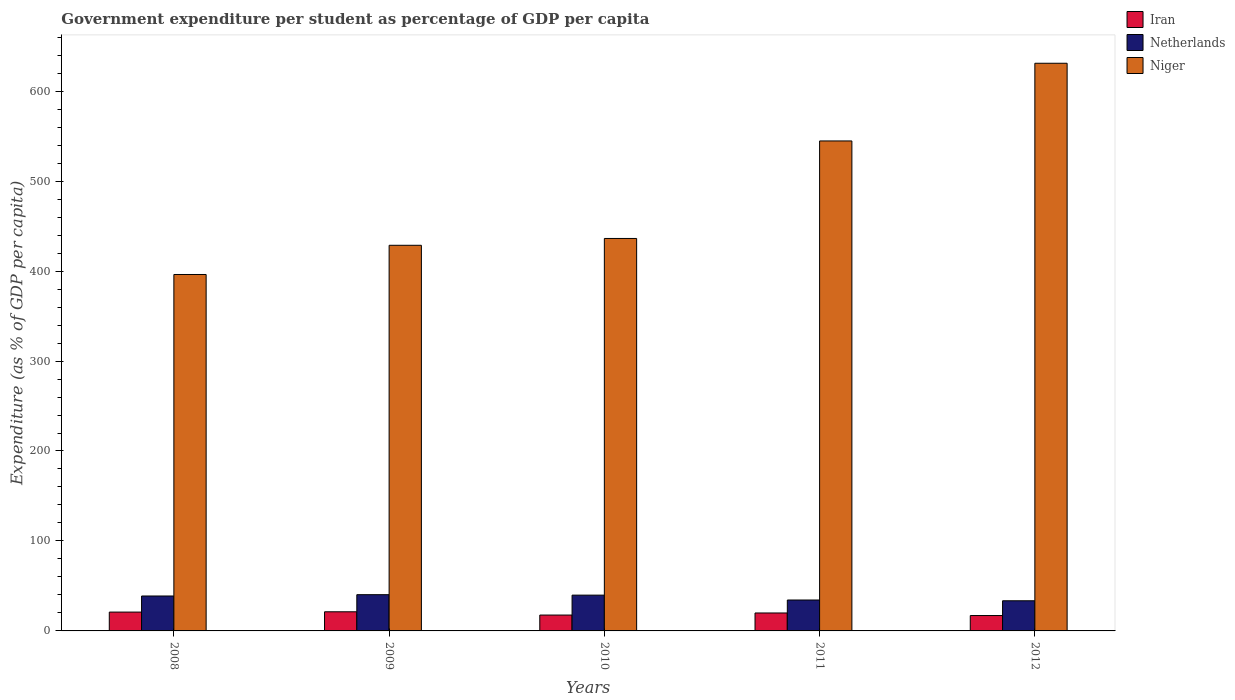How many groups of bars are there?
Offer a very short reply. 5. Are the number of bars per tick equal to the number of legend labels?
Make the answer very short. Yes. Are the number of bars on each tick of the X-axis equal?
Keep it short and to the point. Yes. How many bars are there on the 3rd tick from the right?
Ensure brevity in your answer.  3. What is the percentage of expenditure per student in Niger in 2011?
Keep it short and to the point. 544.64. Across all years, what is the maximum percentage of expenditure per student in Niger?
Offer a terse response. 631. Across all years, what is the minimum percentage of expenditure per student in Netherlands?
Offer a terse response. 33.51. In which year was the percentage of expenditure per student in Netherlands maximum?
Your answer should be very brief. 2009. What is the total percentage of expenditure per student in Niger in the graph?
Offer a very short reply. 2436.77. What is the difference between the percentage of expenditure per student in Niger in 2009 and that in 2011?
Your response must be concise. -115.99. What is the difference between the percentage of expenditure per student in Iran in 2008 and the percentage of expenditure per student in Niger in 2012?
Give a very brief answer. -610.06. What is the average percentage of expenditure per student in Netherlands per year?
Keep it short and to the point. 37.35. In the year 2012, what is the difference between the percentage of expenditure per student in Netherlands and percentage of expenditure per student in Niger?
Your answer should be very brief. -597.49. In how many years, is the percentage of expenditure per student in Niger greater than 60 %?
Give a very brief answer. 5. What is the ratio of the percentage of expenditure per student in Netherlands in 2009 to that in 2011?
Provide a succinct answer. 1.17. Is the percentage of expenditure per student in Niger in 2009 less than that in 2011?
Offer a terse response. Yes. Is the difference between the percentage of expenditure per student in Netherlands in 2008 and 2009 greater than the difference between the percentage of expenditure per student in Niger in 2008 and 2009?
Offer a terse response. Yes. What is the difference between the highest and the second highest percentage of expenditure per student in Netherlands?
Provide a succinct answer. 0.51. What is the difference between the highest and the lowest percentage of expenditure per student in Niger?
Your answer should be compact. 234.8. In how many years, is the percentage of expenditure per student in Niger greater than the average percentage of expenditure per student in Niger taken over all years?
Offer a terse response. 2. Is the sum of the percentage of expenditure per student in Iran in 2008 and 2012 greater than the maximum percentage of expenditure per student in Netherlands across all years?
Your answer should be compact. No. What does the 1st bar from the left in 2009 represents?
Offer a terse response. Iran. How many bars are there?
Your answer should be very brief. 15. Are all the bars in the graph horizontal?
Offer a terse response. No. How many years are there in the graph?
Provide a short and direct response. 5. What is the difference between two consecutive major ticks on the Y-axis?
Your response must be concise. 100. Does the graph contain any zero values?
Provide a succinct answer. No. Does the graph contain grids?
Your answer should be very brief. No. How many legend labels are there?
Keep it short and to the point. 3. What is the title of the graph?
Your answer should be compact. Government expenditure per student as percentage of GDP per capita. Does "Niger" appear as one of the legend labels in the graph?
Offer a terse response. Yes. What is the label or title of the X-axis?
Offer a very short reply. Years. What is the label or title of the Y-axis?
Your answer should be very brief. Expenditure (as % of GDP per capita). What is the Expenditure (as % of GDP per capita) of Iran in 2008?
Offer a terse response. 20.95. What is the Expenditure (as % of GDP per capita) in Netherlands in 2008?
Your response must be concise. 38.82. What is the Expenditure (as % of GDP per capita) of Niger in 2008?
Your answer should be compact. 396.2. What is the Expenditure (as % of GDP per capita) in Iran in 2009?
Make the answer very short. 21.27. What is the Expenditure (as % of GDP per capita) in Netherlands in 2009?
Your answer should be very brief. 40.29. What is the Expenditure (as % of GDP per capita) in Niger in 2009?
Make the answer very short. 428.66. What is the Expenditure (as % of GDP per capita) of Iran in 2010?
Provide a short and direct response. 17.65. What is the Expenditure (as % of GDP per capita) in Netherlands in 2010?
Your response must be concise. 39.78. What is the Expenditure (as % of GDP per capita) in Niger in 2010?
Keep it short and to the point. 436.26. What is the Expenditure (as % of GDP per capita) of Iran in 2011?
Provide a succinct answer. 19.95. What is the Expenditure (as % of GDP per capita) of Netherlands in 2011?
Make the answer very short. 34.36. What is the Expenditure (as % of GDP per capita) of Niger in 2011?
Your answer should be very brief. 544.64. What is the Expenditure (as % of GDP per capita) in Iran in 2012?
Your answer should be compact. 17.09. What is the Expenditure (as % of GDP per capita) of Netherlands in 2012?
Your answer should be very brief. 33.51. What is the Expenditure (as % of GDP per capita) in Niger in 2012?
Provide a short and direct response. 631. Across all years, what is the maximum Expenditure (as % of GDP per capita) in Iran?
Offer a terse response. 21.27. Across all years, what is the maximum Expenditure (as % of GDP per capita) of Netherlands?
Your response must be concise. 40.29. Across all years, what is the maximum Expenditure (as % of GDP per capita) in Niger?
Ensure brevity in your answer.  631. Across all years, what is the minimum Expenditure (as % of GDP per capita) in Iran?
Ensure brevity in your answer.  17.09. Across all years, what is the minimum Expenditure (as % of GDP per capita) in Netherlands?
Offer a terse response. 33.51. Across all years, what is the minimum Expenditure (as % of GDP per capita) in Niger?
Provide a short and direct response. 396.2. What is the total Expenditure (as % of GDP per capita) in Iran in the graph?
Keep it short and to the point. 96.9. What is the total Expenditure (as % of GDP per capita) of Netherlands in the graph?
Your answer should be very brief. 186.77. What is the total Expenditure (as % of GDP per capita) of Niger in the graph?
Make the answer very short. 2436.77. What is the difference between the Expenditure (as % of GDP per capita) in Iran in 2008 and that in 2009?
Offer a terse response. -0.32. What is the difference between the Expenditure (as % of GDP per capita) of Netherlands in 2008 and that in 2009?
Provide a short and direct response. -1.47. What is the difference between the Expenditure (as % of GDP per capita) of Niger in 2008 and that in 2009?
Offer a very short reply. -32.45. What is the difference between the Expenditure (as % of GDP per capita) in Iran in 2008 and that in 2010?
Provide a short and direct response. 3.3. What is the difference between the Expenditure (as % of GDP per capita) of Netherlands in 2008 and that in 2010?
Provide a succinct answer. -0.95. What is the difference between the Expenditure (as % of GDP per capita) of Niger in 2008 and that in 2010?
Your response must be concise. -40.05. What is the difference between the Expenditure (as % of GDP per capita) of Iran in 2008 and that in 2011?
Your response must be concise. 1. What is the difference between the Expenditure (as % of GDP per capita) in Netherlands in 2008 and that in 2011?
Offer a very short reply. 4.46. What is the difference between the Expenditure (as % of GDP per capita) in Niger in 2008 and that in 2011?
Offer a very short reply. -148.44. What is the difference between the Expenditure (as % of GDP per capita) in Iran in 2008 and that in 2012?
Give a very brief answer. 3.85. What is the difference between the Expenditure (as % of GDP per capita) of Netherlands in 2008 and that in 2012?
Your answer should be very brief. 5.31. What is the difference between the Expenditure (as % of GDP per capita) of Niger in 2008 and that in 2012?
Your response must be concise. -234.8. What is the difference between the Expenditure (as % of GDP per capita) of Iran in 2009 and that in 2010?
Offer a very short reply. 3.62. What is the difference between the Expenditure (as % of GDP per capita) in Netherlands in 2009 and that in 2010?
Offer a terse response. 0.51. What is the difference between the Expenditure (as % of GDP per capita) in Niger in 2009 and that in 2010?
Your answer should be compact. -7.6. What is the difference between the Expenditure (as % of GDP per capita) of Iran in 2009 and that in 2011?
Your response must be concise. 1.32. What is the difference between the Expenditure (as % of GDP per capita) in Netherlands in 2009 and that in 2011?
Your response must be concise. 5.93. What is the difference between the Expenditure (as % of GDP per capita) of Niger in 2009 and that in 2011?
Your answer should be compact. -115.99. What is the difference between the Expenditure (as % of GDP per capita) of Iran in 2009 and that in 2012?
Your answer should be compact. 4.17. What is the difference between the Expenditure (as % of GDP per capita) of Netherlands in 2009 and that in 2012?
Give a very brief answer. 6.78. What is the difference between the Expenditure (as % of GDP per capita) of Niger in 2009 and that in 2012?
Ensure brevity in your answer.  -202.35. What is the difference between the Expenditure (as % of GDP per capita) in Iran in 2010 and that in 2011?
Offer a very short reply. -2.3. What is the difference between the Expenditure (as % of GDP per capita) of Netherlands in 2010 and that in 2011?
Provide a short and direct response. 5.42. What is the difference between the Expenditure (as % of GDP per capita) of Niger in 2010 and that in 2011?
Ensure brevity in your answer.  -108.39. What is the difference between the Expenditure (as % of GDP per capita) in Iran in 2010 and that in 2012?
Your answer should be compact. 0.55. What is the difference between the Expenditure (as % of GDP per capita) in Netherlands in 2010 and that in 2012?
Your response must be concise. 6.27. What is the difference between the Expenditure (as % of GDP per capita) in Niger in 2010 and that in 2012?
Your response must be concise. -194.75. What is the difference between the Expenditure (as % of GDP per capita) in Iran in 2011 and that in 2012?
Ensure brevity in your answer.  2.85. What is the difference between the Expenditure (as % of GDP per capita) of Netherlands in 2011 and that in 2012?
Keep it short and to the point. 0.85. What is the difference between the Expenditure (as % of GDP per capita) of Niger in 2011 and that in 2012?
Your response must be concise. -86.36. What is the difference between the Expenditure (as % of GDP per capita) of Iran in 2008 and the Expenditure (as % of GDP per capita) of Netherlands in 2009?
Keep it short and to the point. -19.34. What is the difference between the Expenditure (as % of GDP per capita) of Iran in 2008 and the Expenditure (as % of GDP per capita) of Niger in 2009?
Offer a terse response. -407.71. What is the difference between the Expenditure (as % of GDP per capita) in Netherlands in 2008 and the Expenditure (as % of GDP per capita) in Niger in 2009?
Your answer should be compact. -389.83. What is the difference between the Expenditure (as % of GDP per capita) of Iran in 2008 and the Expenditure (as % of GDP per capita) of Netherlands in 2010?
Keep it short and to the point. -18.83. What is the difference between the Expenditure (as % of GDP per capita) in Iran in 2008 and the Expenditure (as % of GDP per capita) in Niger in 2010?
Offer a terse response. -415.31. What is the difference between the Expenditure (as % of GDP per capita) in Netherlands in 2008 and the Expenditure (as % of GDP per capita) in Niger in 2010?
Your response must be concise. -397.43. What is the difference between the Expenditure (as % of GDP per capita) in Iran in 2008 and the Expenditure (as % of GDP per capita) in Netherlands in 2011?
Keep it short and to the point. -13.42. What is the difference between the Expenditure (as % of GDP per capita) in Iran in 2008 and the Expenditure (as % of GDP per capita) in Niger in 2011?
Provide a short and direct response. -523.7. What is the difference between the Expenditure (as % of GDP per capita) in Netherlands in 2008 and the Expenditure (as % of GDP per capita) in Niger in 2011?
Give a very brief answer. -505.82. What is the difference between the Expenditure (as % of GDP per capita) of Iran in 2008 and the Expenditure (as % of GDP per capita) of Netherlands in 2012?
Your answer should be compact. -12.57. What is the difference between the Expenditure (as % of GDP per capita) in Iran in 2008 and the Expenditure (as % of GDP per capita) in Niger in 2012?
Offer a terse response. -610.06. What is the difference between the Expenditure (as % of GDP per capita) of Netherlands in 2008 and the Expenditure (as % of GDP per capita) of Niger in 2012?
Give a very brief answer. -592.18. What is the difference between the Expenditure (as % of GDP per capita) in Iran in 2009 and the Expenditure (as % of GDP per capita) in Netherlands in 2010?
Offer a terse response. -18.51. What is the difference between the Expenditure (as % of GDP per capita) of Iran in 2009 and the Expenditure (as % of GDP per capita) of Niger in 2010?
Your answer should be very brief. -414.99. What is the difference between the Expenditure (as % of GDP per capita) of Netherlands in 2009 and the Expenditure (as % of GDP per capita) of Niger in 2010?
Offer a very short reply. -395.97. What is the difference between the Expenditure (as % of GDP per capita) in Iran in 2009 and the Expenditure (as % of GDP per capita) in Netherlands in 2011?
Offer a very short reply. -13.1. What is the difference between the Expenditure (as % of GDP per capita) in Iran in 2009 and the Expenditure (as % of GDP per capita) in Niger in 2011?
Provide a succinct answer. -523.38. What is the difference between the Expenditure (as % of GDP per capita) of Netherlands in 2009 and the Expenditure (as % of GDP per capita) of Niger in 2011?
Provide a succinct answer. -504.36. What is the difference between the Expenditure (as % of GDP per capita) of Iran in 2009 and the Expenditure (as % of GDP per capita) of Netherlands in 2012?
Offer a terse response. -12.24. What is the difference between the Expenditure (as % of GDP per capita) of Iran in 2009 and the Expenditure (as % of GDP per capita) of Niger in 2012?
Provide a succinct answer. -609.74. What is the difference between the Expenditure (as % of GDP per capita) in Netherlands in 2009 and the Expenditure (as % of GDP per capita) in Niger in 2012?
Provide a succinct answer. -590.72. What is the difference between the Expenditure (as % of GDP per capita) of Iran in 2010 and the Expenditure (as % of GDP per capita) of Netherlands in 2011?
Your answer should be compact. -16.72. What is the difference between the Expenditure (as % of GDP per capita) of Iran in 2010 and the Expenditure (as % of GDP per capita) of Niger in 2011?
Offer a terse response. -527. What is the difference between the Expenditure (as % of GDP per capita) in Netherlands in 2010 and the Expenditure (as % of GDP per capita) in Niger in 2011?
Your response must be concise. -504.87. What is the difference between the Expenditure (as % of GDP per capita) in Iran in 2010 and the Expenditure (as % of GDP per capita) in Netherlands in 2012?
Give a very brief answer. -15.87. What is the difference between the Expenditure (as % of GDP per capita) of Iran in 2010 and the Expenditure (as % of GDP per capita) of Niger in 2012?
Your answer should be very brief. -613.36. What is the difference between the Expenditure (as % of GDP per capita) in Netherlands in 2010 and the Expenditure (as % of GDP per capita) in Niger in 2012?
Keep it short and to the point. -591.23. What is the difference between the Expenditure (as % of GDP per capita) of Iran in 2011 and the Expenditure (as % of GDP per capita) of Netherlands in 2012?
Your answer should be very brief. -13.56. What is the difference between the Expenditure (as % of GDP per capita) of Iran in 2011 and the Expenditure (as % of GDP per capita) of Niger in 2012?
Keep it short and to the point. -611.06. What is the difference between the Expenditure (as % of GDP per capita) in Netherlands in 2011 and the Expenditure (as % of GDP per capita) in Niger in 2012?
Provide a succinct answer. -596.64. What is the average Expenditure (as % of GDP per capita) in Iran per year?
Keep it short and to the point. 19.38. What is the average Expenditure (as % of GDP per capita) of Netherlands per year?
Offer a terse response. 37.35. What is the average Expenditure (as % of GDP per capita) in Niger per year?
Offer a terse response. 487.35. In the year 2008, what is the difference between the Expenditure (as % of GDP per capita) of Iran and Expenditure (as % of GDP per capita) of Netherlands?
Provide a short and direct response. -17.88. In the year 2008, what is the difference between the Expenditure (as % of GDP per capita) in Iran and Expenditure (as % of GDP per capita) in Niger?
Your response must be concise. -375.26. In the year 2008, what is the difference between the Expenditure (as % of GDP per capita) in Netherlands and Expenditure (as % of GDP per capita) in Niger?
Provide a succinct answer. -357.38. In the year 2009, what is the difference between the Expenditure (as % of GDP per capita) of Iran and Expenditure (as % of GDP per capita) of Netherlands?
Your answer should be compact. -19.02. In the year 2009, what is the difference between the Expenditure (as % of GDP per capita) in Iran and Expenditure (as % of GDP per capita) in Niger?
Keep it short and to the point. -407.39. In the year 2009, what is the difference between the Expenditure (as % of GDP per capita) of Netherlands and Expenditure (as % of GDP per capita) of Niger?
Your response must be concise. -388.37. In the year 2010, what is the difference between the Expenditure (as % of GDP per capita) of Iran and Expenditure (as % of GDP per capita) of Netherlands?
Make the answer very short. -22.13. In the year 2010, what is the difference between the Expenditure (as % of GDP per capita) in Iran and Expenditure (as % of GDP per capita) in Niger?
Your answer should be very brief. -418.61. In the year 2010, what is the difference between the Expenditure (as % of GDP per capita) of Netherlands and Expenditure (as % of GDP per capita) of Niger?
Provide a succinct answer. -396.48. In the year 2011, what is the difference between the Expenditure (as % of GDP per capita) in Iran and Expenditure (as % of GDP per capita) in Netherlands?
Offer a terse response. -14.41. In the year 2011, what is the difference between the Expenditure (as % of GDP per capita) in Iran and Expenditure (as % of GDP per capita) in Niger?
Keep it short and to the point. -524.7. In the year 2011, what is the difference between the Expenditure (as % of GDP per capita) in Netherlands and Expenditure (as % of GDP per capita) in Niger?
Keep it short and to the point. -510.28. In the year 2012, what is the difference between the Expenditure (as % of GDP per capita) in Iran and Expenditure (as % of GDP per capita) in Netherlands?
Ensure brevity in your answer.  -16.42. In the year 2012, what is the difference between the Expenditure (as % of GDP per capita) in Iran and Expenditure (as % of GDP per capita) in Niger?
Your answer should be compact. -613.91. In the year 2012, what is the difference between the Expenditure (as % of GDP per capita) in Netherlands and Expenditure (as % of GDP per capita) in Niger?
Make the answer very short. -597.49. What is the ratio of the Expenditure (as % of GDP per capita) in Iran in 2008 to that in 2009?
Provide a short and direct response. 0.98. What is the ratio of the Expenditure (as % of GDP per capita) in Netherlands in 2008 to that in 2009?
Ensure brevity in your answer.  0.96. What is the ratio of the Expenditure (as % of GDP per capita) of Niger in 2008 to that in 2009?
Offer a terse response. 0.92. What is the ratio of the Expenditure (as % of GDP per capita) in Iran in 2008 to that in 2010?
Provide a short and direct response. 1.19. What is the ratio of the Expenditure (as % of GDP per capita) of Niger in 2008 to that in 2010?
Make the answer very short. 0.91. What is the ratio of the Expenditure (as % of GDP per capita) of Netherlands in 2008 to that in 2011?
Keep it short and to the point. 1.13. What is the ratio of the Expenditure (as % of GDP per capita) of Niger in 2008 to that in 2011?
Your response must be concise. 0.73. What is the ratio of the Expenditure (as % of GDP per capita) in Iran in 2008 to that in 2012?
Your answer should be compact. 1.23. What is the ratio of the Expenditure (as % of GDP per capita) of Netherlands in 2008 to that in 2012?
Give a very brief answer. 1.16. What is the ratio of the Expenditure (as % of GDP per capita) in Niger in 2008 to that in 2012?
Your response must be concise. 0.63. What is the ratio of the Expenditure (as % of GDP per capita) of Iran in 2009 to that in 2010?
Provide a succinct answer. 1.21. What is the ratio of the Expenditure (as % of GDP per capita) of Netherlands in 2009 to that in 2010?
Keep it short and to the point. 1.01. What is the ratio of the Expenditure (as % of GDP per capita) in Niger in 2009 to that in 2010?
Provide a short and direct response. 0.98. What is the ratio of the Expenditure (as % of GDP per capita) in Iran in 2009 to that in 2011?
Provide a short and direct response. 1.07. What is the ratio of the Expenditure (as % of GDP per capita) of Netherlands in 2009 to that in 2011?
Offer a very short reply. 1.17. What is the ratio of the Expenditure (as % of GDP per capita) of Niger in 2009 to that in 2011?
Make the answer very short. 0.79. What is the ratio of the Expenditure (as % of GDP per capita) in Iran in 2009 to that in 2012?
Your answer should be very brief. 1.24. What is the ratio of the Expenditure (as % of GDP per capita) of Netherlands in 2009 to that in 2012?
Provide a short and direct response. 1.2. What is the ratio of the Expenditure (as % of GDP per capita) in Niger in 2009 to that in 2012?
Provide a short and direct response. 0.68. What is the ratio of the Expenditure (as % of GDP per capita) of Iran in 2010 to that in 2011?
Provide a short and direct response. 0.88. What is the ratio of the Expenditure (as % of GDP per capita) of Netherlands in 2010 to that in 2011?
Make the answer very short. 1.16. What is the ratio of the Expenditure (as % of GDP per capita) of Niger in 2010 to that in 2011?
Your answer should be very brief. 0.8. What is the ratio of the Expenditure (as % of GDP per capita) in Iran in 2010 to that in 2012?
Give a very brief answer. 1.03. What is the ratio of the Expenditure (as % of GDP per capita) in Netherlands in 2010 to that in 2012?
Your answer should be very brief. 1.19. What is the ratio of the Expenditure (as % of GDP per capita) of Niger in 2010 to that in 2012?
Offer a very short reply. 0.69. What is the ratio of the Expenditure (as % of GDP per capita) in Iran in 2011 to that in 2012?
Ensure brevity in your answer.  1.17. What is the ratio of the Expenditure (as % of GDP per capita) of Netherlands in 2011 to that in 2012?
Provide a short and direct response. 1.03. What is the ratio of the Expenditure (as % of GDP per capita) of Niger in 2011 to that in 2012?
Provide a succinct answer. 0.86. What is the difference between the highest and the second highest Expenditure (as % of GDP per capita) of Iran?
Give a very brief answer. 0.32. What is the difference between the highest and the second highest Expenditure (as % of GDP per capita) in Netherlands?
Give a very brief answer. 0.51. What is the difference between the highest and the second highest Expenditure (as % of GDP per capita) of Niger?
Offer a very short reply. 86.36. What is the difference between the highest and the lowest Expenditure (as % of GDP per capita) of Iran?
Provide a succinct answer. 4.17. What is the difference between the highest and the lowest Expenditure (as % of GDP per capita) of Netherlands?
Provide a succinct answer. 6.78. What is the difference between the highest and the lowest Expenditure (as % of GDP per capita) in Niger?
Make the answer very short. 234.8. 